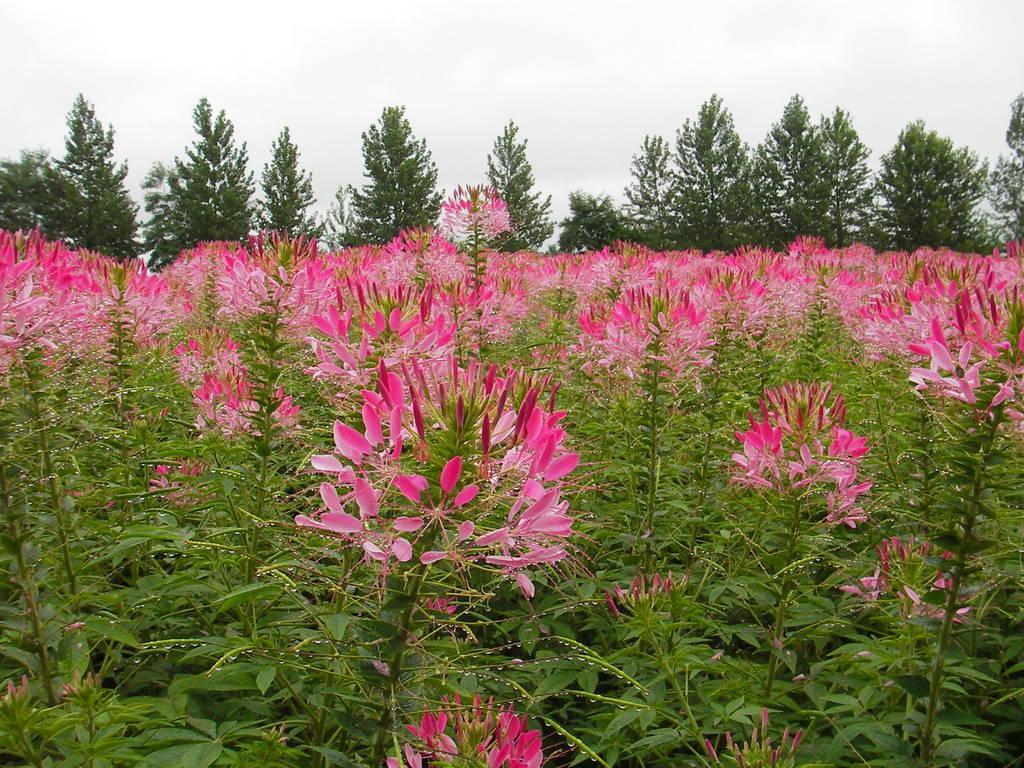In one or two sentences, can you explain what this image depicts? This picture is taken from the outside of the city. In this image, we can see some plants with flowers which are in pink in color. In the background, we can see some trees. At the top, we can see a sky. 